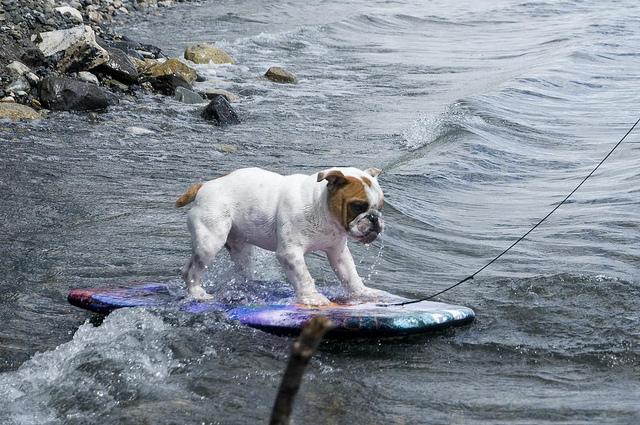What is behind the dog?
Short answer required. Rocks. What are the colors of the dogs?
Write a very short answer. Brown and white. Was this photo taken through glass?
Answer briefly. No. Is this animal a mammal?
Quick response, please. Yes. What living being do you see in the image?
Give a very brief answer. Dog. What is he on?
Give a very brief answer. Boogie board. 